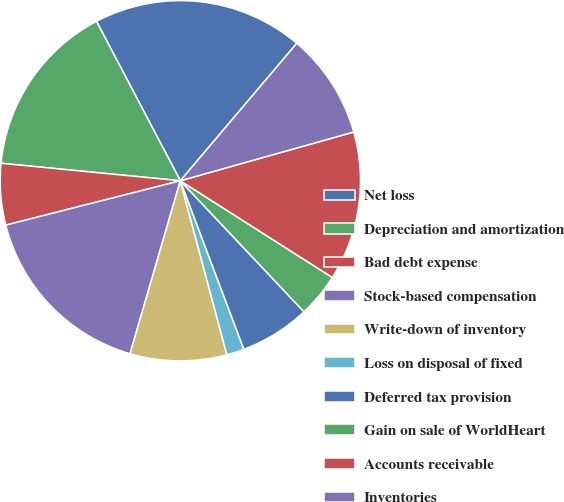<chart> <loc_0><loc_0><loc_500><loc_500><pie_chart><fcel>Net loss<fcel>Depreciation and amortization<fcel>Bad debt expense<fcel>Stock-based compensation<fcel>Write-down of inventory<fcel>Loss on disposal of fixed<fcel>Deferred tax provision<fcel>Gain on sale of WorldHeart<fcel>Accounts receivable<fcel>Inventories<nl><fcel>18.89%<fcel>15.74%<fcel>5.51%<fcel>16.53%<fcel>8.66%<fcel>1.58%<fcel>6.3%<fcel>3.94%<fcel>13.38%<fcel>9.45%<nl></chart> 